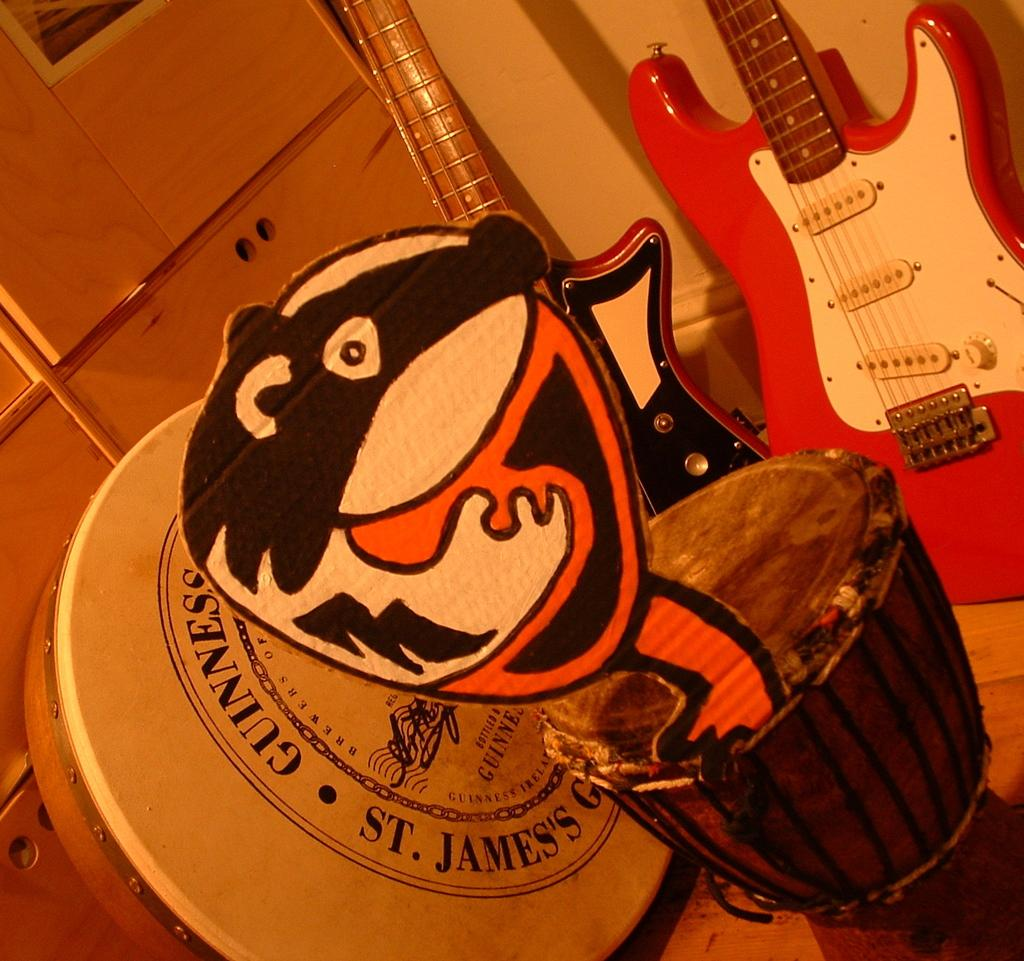How many drums are visible in the image? There are 2 drums in the image. How many guitars are visible in the image? There are 2 guitars in the image. Where are the drums and guitars positioned in the image? The drums and guitars are leaned against a wall. What type of corn is being used as a drumstick in the image? There is no corn present in the image, and no drumsticks are being used. 